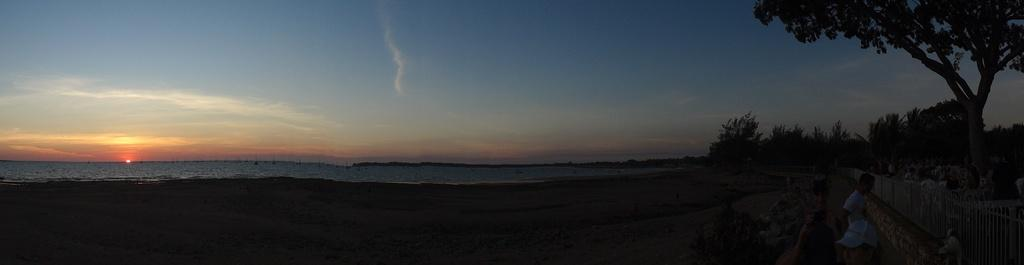What type of location is depicted in the image? There is a beach in the image. What can be seen on the right side of the image? There is a fencing on the right side of the image. What is the person near the fencing doing? A person is standing near the fencing. What type of vegetation is present in the image? There are trees in the image. What is visible in the background of the image? The sea and the sky are visible in the background of the image. What type of humor can be seen in the farmer's facial expression in the image? There is no farmer present in the image, and therefore no facial expression to analyze for humor. 